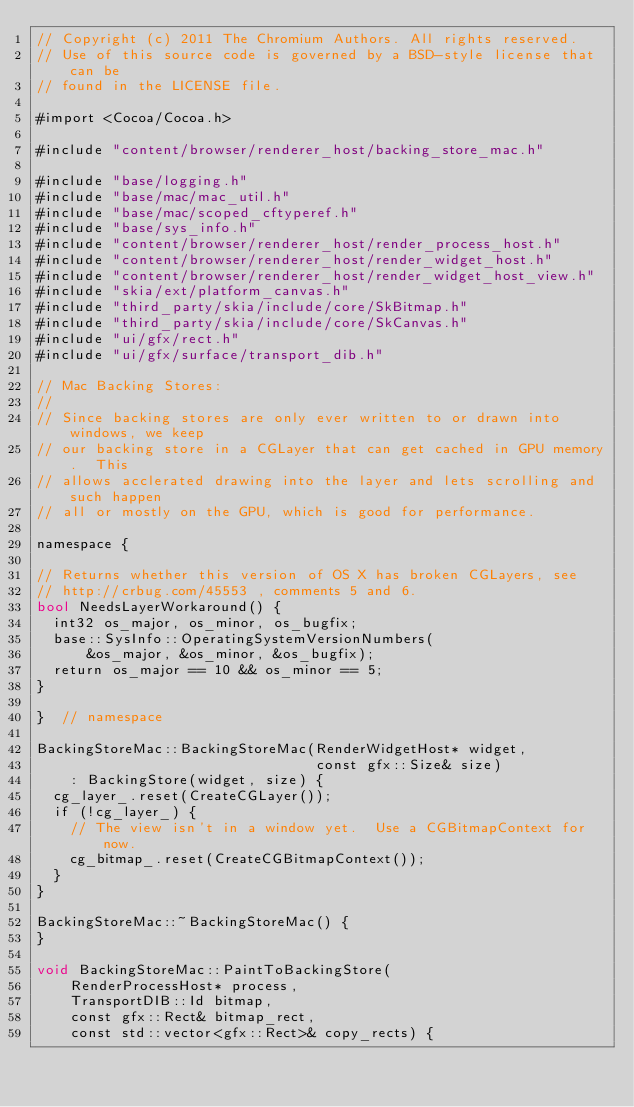Convert code to text. <code><loc_0><loc_0><loc_500><loc_500><_ObjectiveC_>// Copyright (c) 2011 The Chromium Authors. All rights reserved.
// Use of this source code is governed by a BSD-style license that can be
// found in the LICENSE file.

#import <Cocoa/Cocoa.h>

#include "content/browser/renderer_host/backing_store_mac.h"

#include "base/logging.h"
#include "base/mac/mac_util.h"
#include "base/mac/scoped_cftyperef.h"
#include "base/sys_info.h"
#include "content/browser/renderer_host/render_process_host.h"
#include "content/browser/renderer_host/render_widget_host.h"
#include "content/browser/renderer_host/render_widget_host_view.h"
#include "skia/ext/platform_canvas.h"
#include "third_party/skia/include/core/SkBitmap.h"
#include "third_party/skia/include/core/SkCanvas.h"
#include "ui/gfx/rect.h"
#include "ui/gfx/surface/transport_dib.h"

// Mac Backing Stores:
//
// Since backing stores are only ever written to or drawn into windows, we keep
// our backing store in a CGLayer that can get cached in GPU memory.  This
// allows acclerated drawing into the layer and lets scrolling and such happen
// all or mostly on the GPU, which is good for performance.

namespace {

// Returns whether this version of OS X has broken CGLayers, see
// http://crbug.com/45553 , comments 5 and 6.
bool NeedsLayerWorkaround() {
  int32 os_major, os_minor, os_bugfix;
  base::SysInfo::OperatingSystemVersionNumbers(
      &os_major, &os_minor, &os_bugfix);
  return os_major == 10 && os_minor == 5;
}

}  // namespace

BackingStoreMac::BackingStoreMac(RenderWidgetHost* widget,
                                 const gfx::Size& size)
    : BackingStore(widget, size) {
  cg_layer_.reset(CreateCGLayer());
  if (!cg_layer_) {
    // The view isn't in a window yet.  Use a CGBitmapContext for now.
    cg_bitmap_.reset(CreateCGBitmapContext());
  }
}

BackingStoreMac::~BackingStoreMac() {
}

void BackingStoreMac::PaintToBackingStore(
    RenderProcessHost* process,
    TransportDIB::Id bitmap,
    const gfx::Rect& bitmap_rect,
    const std::vector<gfx::Rect>& copy_rects) {</code> 